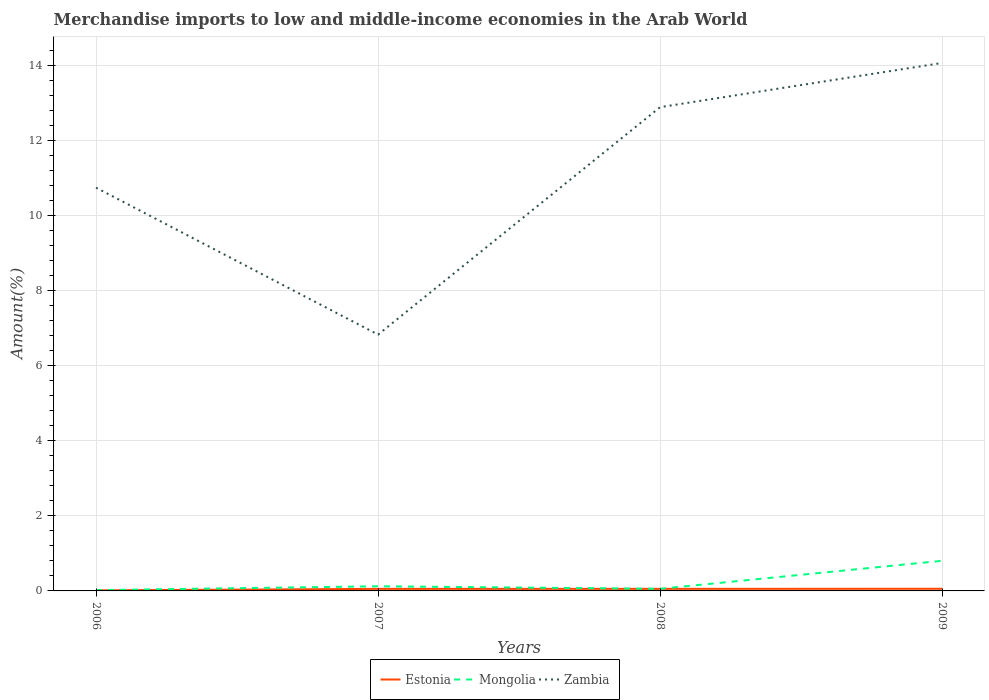How many different coloured lines are there?
Provide a short and direct response. 3. Does the line corresponding to Estonia intersect with the line corresponding to Zambia?
Your response must be concise. No. Is the number of lines equal to the number of legend labels?
Your answer should be compact. Yes. Across all years, what is the maximum percentage of amount earned from merchandise imports in Zambia?
Keep it short and to the point. 6.83. What is the total percentage of amount earned from merchandise imports in Mongolia in the graph?
Offer a terse response. -0.03. What is the difference between the highest and the second highest percentage of amount earned from merchandise imports in Estonia?
Offer a very short reply. 0.04. What is the difference between the highest and the lowest percentage of amount earned from merchandise imports in Mongolia?
Offer a terse response. 1. How many lines are there?
Make the answer very short. 3. How many years are there in the graph?
Make the answer very short. 4. What is the difference between two consecutive major ticks on the Y-axis?
Give a very brief answer. 2. Are the values on the major ticks of Y-axis written in scientific E-notation?
Your response must be concise. No. Does the graph contain any zero values?
Your response must be concise. No. How many legend labels are there?
Keep it short and to the point. 3. What is the title of the graph?
Provide a succinct answer. Merchandise imports to low and middle-income economies in the Arab World. What is the label or title of the X-axis?
Offer a terse response. Years. What is the label or title of the Y-axis?
Offer a very short reply. Amount(%). What is the Amount(%) of Estonia in 2006?
Offer a terse response. 0.02. What is the Amount(%) in Mongolia in 2006?
Provide a short and direct response. 0.02. What is the Amount(%) in Zambia in 2006?
Your response must be concise. 10.75. What is the Amount(%) of Estonia in 2007?
Offer a terse response. 0.05. What is the Amount(%) in Mongolia in 2007?
Give a very brief answer. 0.12. What is the Amount(%) in Zambia in 2007?
Provide a succinct answer. 6.83. What is the Amount(%) of Estonia in 2008?
Offer a very short reply. 0.06. What is the Amount(%) in Mongolia in 2008?
Ensure brevity in your answer.  0.06. What is the Amount(%) of Zambia in 2008?
Give a very brief answer. 12.9. What is the Amount(%) of Estonia in 2009?
Give a very brief answer. 0.06. What is the Amount(%) of Mongolia in 2009?
Ensure brevity in your answer.  0.8. What is the Amount(%) of Zambia in 2009?
Your answer should be compact. 14.08. Across all years, what is the maximum Amount(%) in Estonia?
Provide a succinct answer. 0.06. Across all years, what is the maximum Amount(%) in Mongolia?
Your answer should be very brief. 0.8. Across all years, what is the maximum Amount(%) of Zambia?
Keep it short and to the point. 14.08. Across all years, what is the minimum Amount(%) in Estonia?
Ensure brevity in your answer.  0.02. Across all years, what is the minimum Amount(%) in Mongolia?
Make the answer very short. 0.02. Across all years, what is the minimum Amount(%) of Zambia?
Give a very brief answer. 6.83. What is the total Amount(%) in Estonia in the graph?
Your answer should be very brief. 0.18. What is the total Amount(%) in Zambia in the graph?
Offer a terse response. 44.56. What is the difference between the Amount(%) in Estonia in 2006 and that in 2007?
Provide a succinct answer. -0.04. What is the difference between the Amount(%) of Mongolia in 2006 and that in 2007?
Provide a short and direct response. -0.1. What is the difference between the Amount(%) of Zambia in 2006 and that in 2007?
Make the answer very short. 3.92. What is the difference between the Amount(%) of Estonia in 2006 and that in 2008?
Make the answer very short. -0.04. What is the difference between the Amount(%) in Mongolia in 2006 and that in 2008?
Your response must be concise. -0.03. What is the difference between the Amount(%) of Zambia in 2006 and that in 2008?
Your answer should be compact. -2.15. What is the difference between the Amount(%) in Estonia in 2006 and that in 2009?
Offer a terse response. -0.04. What is the difference between the Amount(%) in Mongolia in 2006 and that in 2009?
Keep it short and to the point. -0.78. What is the difference between the Amount(%) in Zambia in 2006 and that in 2009?
Offer a very short reply. -3.33. What is the difference between the Amount(%) in Estonia in 2007 and that in 2008?
Keep it short and to the point. -0. What is the difference between the Amount(%) in Mongolia in 2007 and that in 2008?
Provide a short and direct response. 0.07. What is the difference between the Amount(%) of Zambia in 2007 and that in 2008?
Provide a succinct answer. -6.06. What is the difference between the Amount(%) in Estonia in 2007 and that in 2009?
Make the answer very short. -0. What is the difference between the Amount(%) of Mongolia in 2007 and that in 2009?
Your response must be concise. -0.68. What is the difference between the Amount(%) of Zambia in 2007 and that in 2009?
Your answer should be compact. -7.24. What is the difference between the Amount(%) of Estonia in 2008 and that in 2009?
Offer a terse response. -0. What is the difference between the Amount(%) of Mongolia in 2008 and that in 2009?
Keep it short and to the point. -0.75. What is the difference between the Amount(%) in Zambia in 2008 and that in 2009?
Offer a very short reply. -1.18. What is the difference between the Amount(%) of Estonia in 2006 and the Amount(%) of Mongolia in 2007?
Make the answer very short. -0.11. What is the difference between the Amount(%) in Estonia in 2006 and the Amount(%) in Zambia in 2007?
Give a very brief answer. -6.82. What is the difference between the Amount(%) in Mongolia in 2006 and the Amount(%) in Zambia in 2007?
Give a very brief answer. -6.81. What is the difference between the Amount(%) in Estonia in 2006 and the Amount(%) in Mongolia in 2008?
Offer a terse response. -0.04. What is the difference between the Amount(%) of Estonia in 2006 and the Amount(%) of Zambia in 2008?
Your response must be concise. -12.88. What is the difference between the Amount(%) of Mongolia in 2006 and the Amount(%) of Zambia in 2008?
Provide a short and direct response. -12.88. What is the difference between the Amount(%) of Estonia in 2006 and the Amount(%) of Mongolia in 2009?
Provide a succinct answer. -0.79. What is the difference between the Amount(%) of Estonia in 2006 and the Amount(%) of Zambia in 2009?
Your response must be concise. -14.06. What is the difference between the Amount(%) of Mongolia in 2006 and the Amount(%) of Zambia in 2009?
Give a very brief answer. -14.06. What is the difference between the Amount(%) in Estonia in 2007 and the Amount(%) in Mongolia in 2008?
Your answer should be compact. -0. What is the difference between the Amount(%) in Estonia in 2007 and the Amount(%) in Zambia in 2008?
Your response must be concise. -12.84. What is the difference between the Amount(%) of Mongolia in 2007 and the Amount(%) of Zambia in 2008?
Ensure brevity in your answer.  -12.78. What is the difference between the Amount(%) in Estonia in 2007 and the Amount(%) in Mongolia in 2009?
Keep it short and to the point. -0.75. What is the difference between the Amount(%) of Estonia in 2007 and the Amount(%) of Zambia in 2009?
Your answer should be very brief. -14.02. What is the difference between the Amount(%) in Mongolia in 2007 and the Amount(%) in Zambia in 2009?
Your answer should be compact. -13.95. What is the difference between the Amount(%) of Estonia in 2008 and the Amount(%) of Mongolia in 2009?
Your response must be concise. -0.75. What is the difference between the Amount(%) in Estonia in 2008 and the Amount(%) in Zambia in 2009?
Ensure brevity in your answer.  -14.02. What is the difference between the Amount(%) of Mongolia in 2008 and the Amount(%) of Zambia in 2009?
Offer a very short reply. -14.02. What is the average Amount(%) in Estonia per year?
Your response must be concise. 0.05. What is the average Amount(%) in Mongolia per year?
Offer a terse response. 0.25. What is the average Amount(%) in Zambia per year?
Your answer should be very brief. 11.14. In the year 2006, what is the difference between the Amount(%) in Estonia and Amount(%) in Mongolia?
Make the answer very short. -0.01. In the year 2006, what is the difference between the Amount(%) of Estonia and Amount(%) of Zambia?
Offer a very short reply. -10.74. In the year 2006, what is the difference between the Amount(%) of Mongolia and Amount(%) of Zambia?
Your response must be concise. -10.73. In the year 2007, what is the difference between the Amount(%) of Estonia and Amount(%) of Mongolia?
Provide a succinct answer. -0.07. In the year 2007, what is the difference between the Amount(%) in Estonia and Amount(%) in Zambia?
Give a very brief answer. -6.78. In the year 2007, what is the difference between the Amount(%) of Mongolia and Amount(%) of Zambia?
Your response must be concise. -6.71. In the year 2008, what is the difference between the Amount(%) of Estonia and Amount(%) of Mongolia?
Make the answer very short. -0. In the year 2008, what is the difference between the Amount(%) of Estonia and Amount(%) of Zambia?
Keep it short and to the point. -12.84. In the year 2008, what is the difference between the Amount(%) of Mongolia and Amount(%) of Zambia?
Give a very brief answer. -12.84. In the year 2009, what is the difference between the Amount(%) in Estonia and Amount(%) in Mongolia?
Your answer should be very brief. -0.75. In the year 2009, what is the difference between the Amount(%) of Estonia and Amount(%) of Zambia?
Provide a succinct answer. -14.02. In the year 2009, what is the difference between the Amount(%) in Mongolia and Amount(%) in Zambia?
Your answer should be very brief. -13.27. What is the ratio of the Amount(%) of Estonia in 2006 to that in 2007?
Make the answer very short. 0.28. What is the ratio of the Amount(%) in Mongolia in 2006 to that in 2007?
Give a very brief answer. 0.18. What is the ratio of the Amount(%) in Zambia in 2006 to that in 2007?
Make the answer very short. 1.57. What is the ratio of the Amount(%) of Estonia in 2006 to that in 2008?
Your answer should be compact. 0.27. What is the ratio of the Amount(%) of Mongolia in 2006 to that in 2008?
Offer a very short reply. 0.39. What is the ratio of the Amount(%) of Zambia in 2006 to that in 2008?
Make the answer very short. 0.83. What is the ratio of the Amount(%) of Estonia in 2006 to that in 2009?
Your answer should be compact. 0.26. What is the ratio of the Amount(%) of Mongolia in 2006 to that in 2009?
Your answer should be very brief. 0.03. What is the ratio of the Amount(%) of Zambia in 2006 to that in 2009?
Make the answer very short. 0.76. What is the ratio of the Amount(%) in Estonia in 2007 to that in 2008?
Make the answer very short. 0.99. What is the ratio of the Amount(%) of Mongolia in 2007 to that in 2008?
Provide a succinct answer. 2.17. What is the ratio of the Amount(%) in Zambia in 2007 to that in 2008?
Offer a very short reply. 0.53. What is the ratio of the Amount(%) of Estonia in 2007 to that in 2009?
Ensure brevity in your answer.  0.95. What is the ratio of the Amount(%) of Mongolia in 2007 to that in 2009?
Provide a short and direct response. 0.15. What is the ratio of the Amount(%) in Zambia in 2007 to that in 2009?
Provide a succinct answer. 0.49. What is the ratio of the Amount(%) of Estonia in 2008 to that in 2009?
Provide a succinct answer. 0.96. What is the ratio of the Amount(%) in Mongolia in 2008 to that in 2009?
Offer a very short reply. 0.07. What is the ratio of the Amount(%) in Zambia in 2008 to that in 2009?
Offer a very short reply. 0.92. What is the difference between the highest and the second highest Amount(%) in Estonia?
Make the answer very short. 0. What is the difference between the highest and the second highest Amount(%) in Mongolia?
Offer a very short reply. 0.68. What is the difference between the highest and the second highest Amount(%) in Zambia?
Your response must be concise. 1.18. What is the difference between the highest and the lowest Amount(%) of Estonia?
Provide a succinct answer. 0.04. What is the difference between the highest and the lowest Amount(%) in Mongolia?
Your answer should be compact. 0.78. What is the difference between the highest and the lowest Amount(%) in Zambia?
Offer a very short reply. 7.24. 